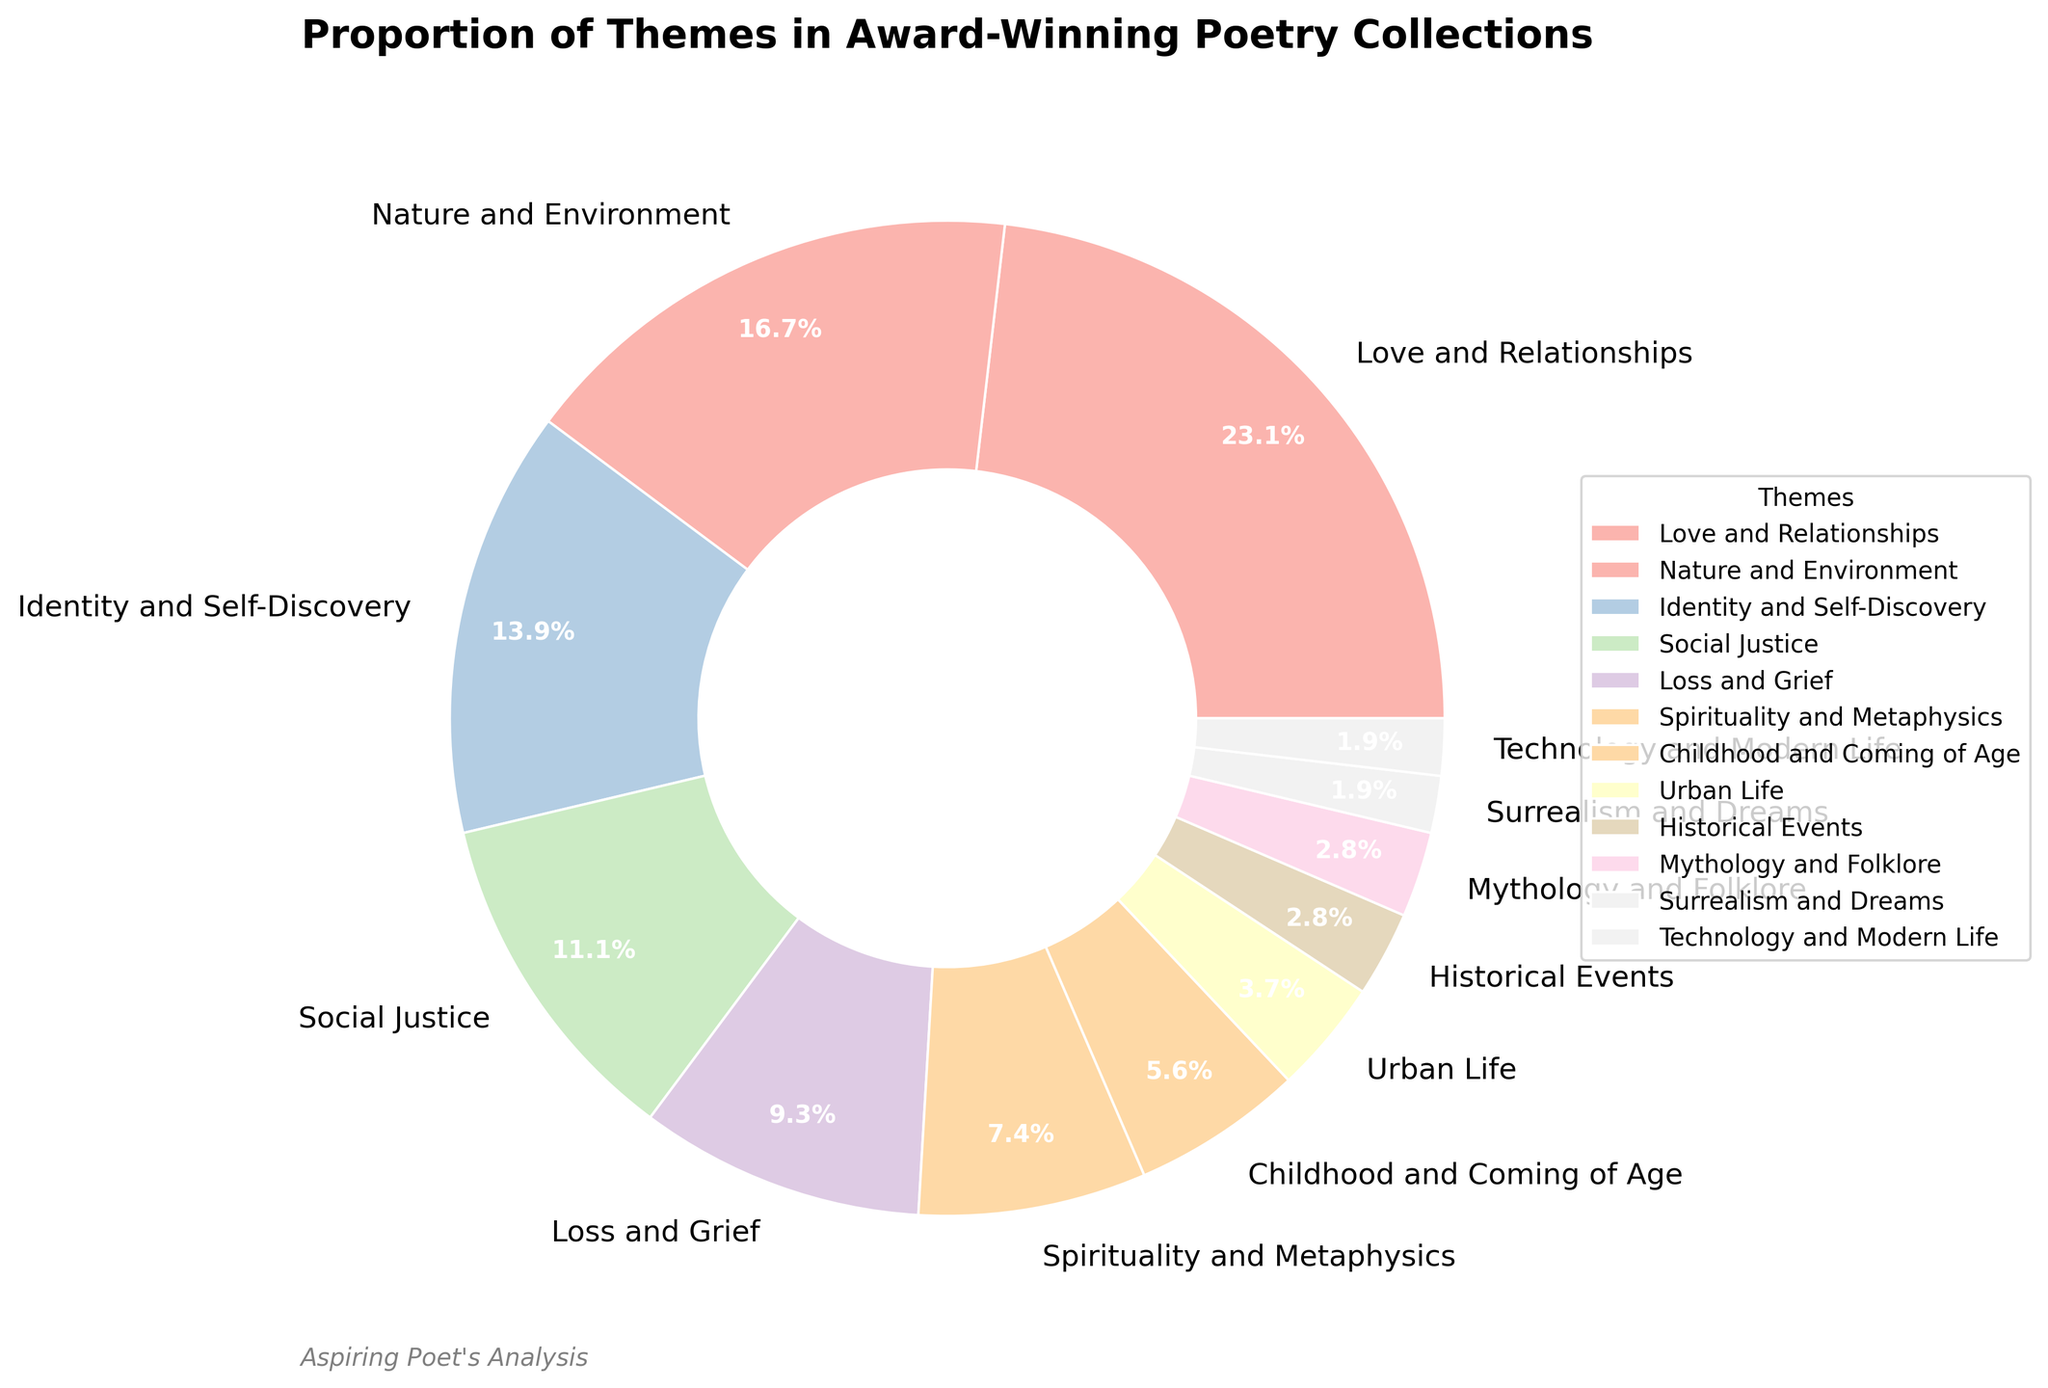What's the largest theme in the award-winning poetry collections? The largest portion of the pie chart is "Love and Relationships" which occupies the largest area.
Answer: Love and Relationships Which theme appears the least in the award-winning poetry collections? The smallest portions of the pie chart are "Surrealism and Dreams" and "Technology and Modern Life," each representing 2%.
Answer: Surrealism and Dreams, Technology and Modern Life What is the combined percentage of "Social Justice" and "Spirituality and Metaphysics"? "Social Justice" is 12% and "Spirituality and Metaphysics" is 8%. Adding them together gives 12% + 8% = 20%.
Answer: 20% Is "Identity and Self-Discovery" more common than "Nature and Environment"? "Identity and Self-Discovery" has 15% while "Nature and Environment" has 18%. Since 15% is less than 18%, "Identity and Self-Discovery" is less common.
Answer: No Which theme has a proportion closest to "Loss and Grief"? "Loss and Grief" has 10%. The theme closest to 10% is "Spirituality and Metaphysics" with 8%.
Answer: Spirituality and Metaphysics How many themes have a proportion greater than 10%? The themes with proportions greater than 10% are "Love and Relationships" (25%), "Nature and Environment" (18%), "Identity and Self-Discovery" (15%), and "Social Justice" (12%). There are four themes in total.
Answer: 4 What is the total percentage of themes related to personal experience (Love and Relationships, Identity and Self-Discovery, Childhood and Coming of Age)? The percentages are 25% (Love and Relationships), 15% (Identity and Self-Discovery), and 6% (Childhood and Coming of Age). Adding them gives 25% + 15% + 6% = 46%.
Answer: 46% Are themes related to "Mythology and Folklore" more frequent than those related to "Historical Events"? Both themes "Mythology and Folklore" and "Historical Events" have the same percentage, 3%. Thus, they occur equally.
Answer: No What is the average proportion of "Urban Life", "Historical Events", and "Technology and Modern Life" themes? The percentages are 4% (Urban Life), 3% (Historical Events), and 2% (Technology and Modern Life). The sum is 4% + 3% + 2% = 9%. Dividing by the number of themes, the average is 9% / 3 = 3%.
Answer: 3% Which theme occupies the second-largest area in the chart? The second-largest theme in the chart is "Nature and Environment" with 18%.
Answer: Nature and Environment 